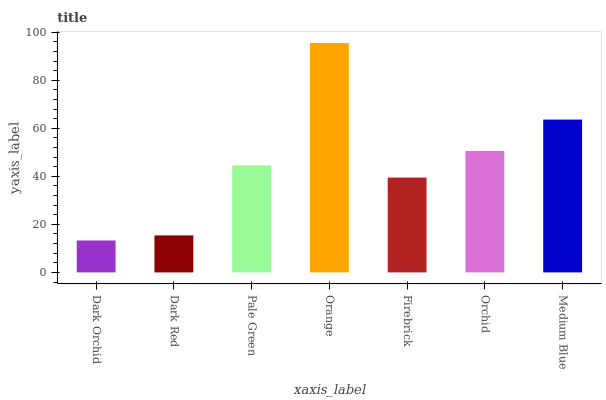Is Dark Orchid the minimum?
Answer yes or no. Yes. Is Orange the maximum?
Answer yes or no. Yes. Is Dark Red the minimum?
Answer yes or no. No. Is Dark Red the maximum?
Answer yes or no. No. Is Dark Red greater than Dark Orchid?
Answer yes or no. Yes. Is Dark Orchid less than Dark Red?
Answer yes or no. Yes. Is Dark Orchid greater than Dark Red?
Answer yes or no. No. Is Dark Red less than Dark Orchid?
Answer yes or no. No. Is Pale Green the high median?
Answer yes or no. Yes. Is Pale Green the low median?
Answer yes or no. Yes. Is Dark Red the high median?
Answer yes or no. No. Is Medium Blue the low median?
Answer yes or no. No. 